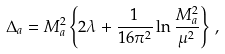<formula> <loc_0><loc_0><loc_500><loc_500>\Delta _ { a } = M _ { a } ^ { 2 } \left \{ 2 \lambda + \frac { 1 } { 1 6 \pi ^ { 2 } } \ln \frac { M _ { a } ^ { 2 } } { \mu ^ { 2 } } \right \} \, ,</formula> 